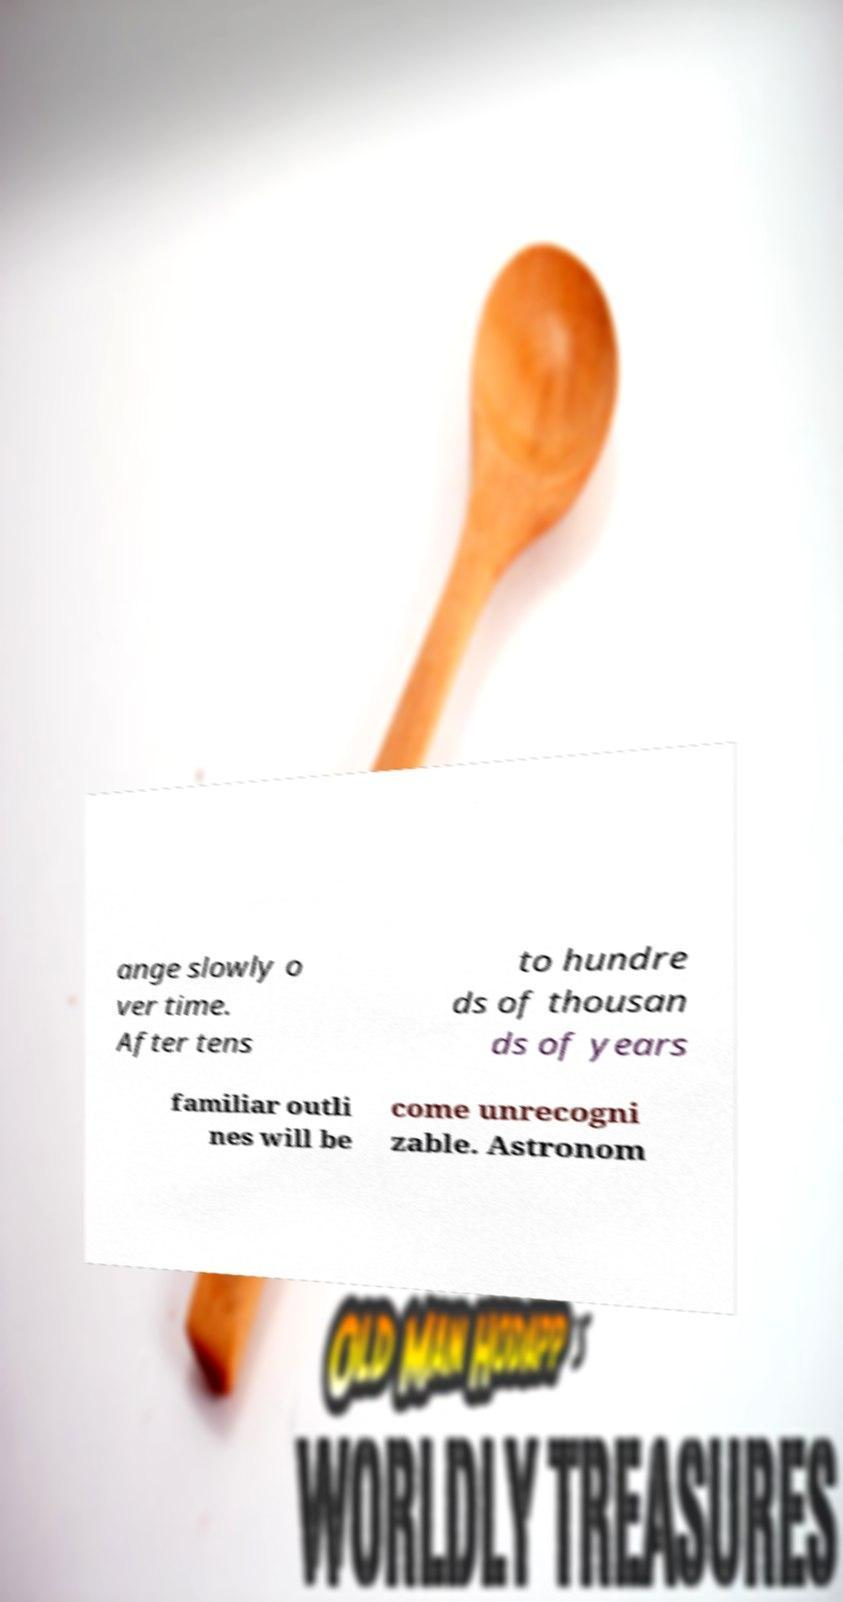For documentation purposes, I need the text within this image transcribed. Could you provide that? ange slowly o ver time. After tens to hundre ds of thousan ds of years familiar outli nes will be come unrecogni zable. Astronom 